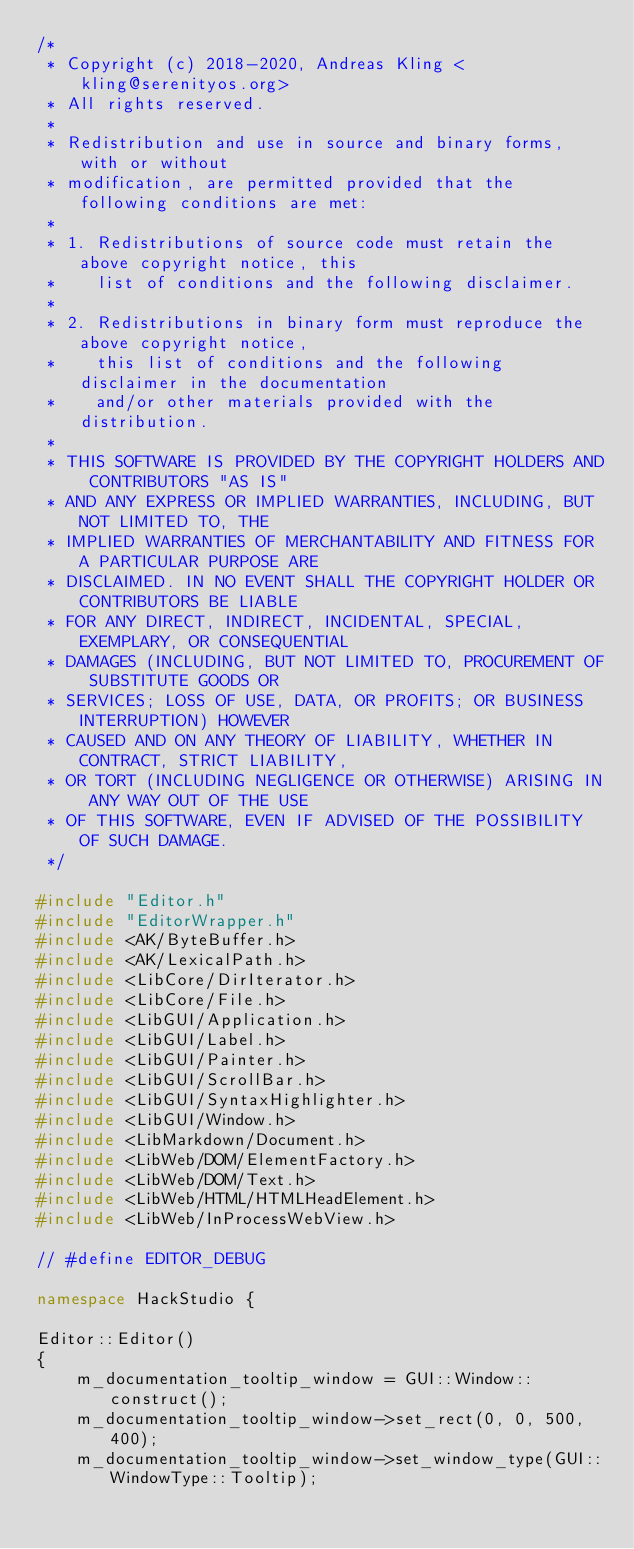Convert code to text. <code><loc_0><loc_0><loc_500><loc_500><_C++_>/*
 * Copyright (c) 2018-2020, Andreas Kling <kling@serenityos.org>
 * All rights reserved.
 *
 * Redistribution and use in source and binary forms, with or without
 * modification, are permitted provided that the following conditions are met:
 *
 * 1. Redistributions of source code must retain the above copyright notice, this
 *    list of conditions and the following disclaimer.
 *
 * 2. Redistributions in binary form must reproduce the above copyright notice,
 *    this list of conditions and the following disclaimer in the documentation
 *    and/or other materials provided with the distribution.
 *
 * THIS SOFTWARE IS PROVIDED BY THE COPYRIGHT HOLDERS AND CONTRIBUTORS "AS IS"
 * AND ANY EXPRESS OR IMPLIED WARRANTIES, INCLUDING, BUT NOT LIMITED TO, THE
 * IMPLIED WARRANTIES OF MERCHANTABILITY AND FITNESS FOR A PARTICULAR PURPOSE ARE
 * DISCLAIMED. IN NO EVENT SHALL THE COPYRIGHT HOLDER OR CONTRIBUTORS BE LIABLE
 * FOR ANY DIRECT, INDIRECT, INCIDENTAL, SPECIAL, EXEMPLARY, OR CONSEQUENTIAL
 * DAMAGES (INCLUDING, BUT NOT LIMITED TO, PROCUREMENT OF SUBSTITUTE GOODS OR
 * SERVICES; LOSS OF USE, DATA, OR PROFITS; OR BUSINESS INTERRUPTION) HOWEVER
 * CAUSED AND ON ANY THEORY OF LIABILITY, WHETHER IN CONTRACT, STRICT LIABILITY,
 * OR TORT (INCLUDING NEGLIGENCE OR OTHERWISE) ARISING IN ANY WAY OUT OF THE USE
 * OF THIS SOFTWARE, EVEN IF ADVISED OF THE POSSIBILITY OF SUCH DAMAGE.
 */

#include "Editor.h"
#include "EditorWrapper.h"
#include <AK/ByteBuffer.h>
#include <AK/LexicalPath.h>
#include <LibCore/DirIterator.h>
#include <LibCore/File.h>
#include <LibGUI/Application.h>
#include <LibGUI/Label.h>
#include <LibGUI/Painter.h>
#include <LibGUI/ScrollBar.h>
#include <LibGUI/SyntaxHighlighter.h>
#include <LibGUI/Window.h>
#include <LibMarkdown/Document.h>
#include <LibWeb/DOM/ElementFactory.h>
#include <LibWeb/DOM/Text.h>
#include <LibWeb/HTML/HTMLHeadElement.h>
#include <LibWeb/InProcessWebView.h>

// #define EDITOR_DEBUG

namespace HackStudio {

Editor::Editor()
{
    m_documentation_tooltip_window = GUI::Window::construct();
    m_documentation_tooltip_window->set_rect(0, 0, 500, 400);
    m_documentation_tooltip_window->set_window_type(GUI::WindowType::Tooltip);</code> 